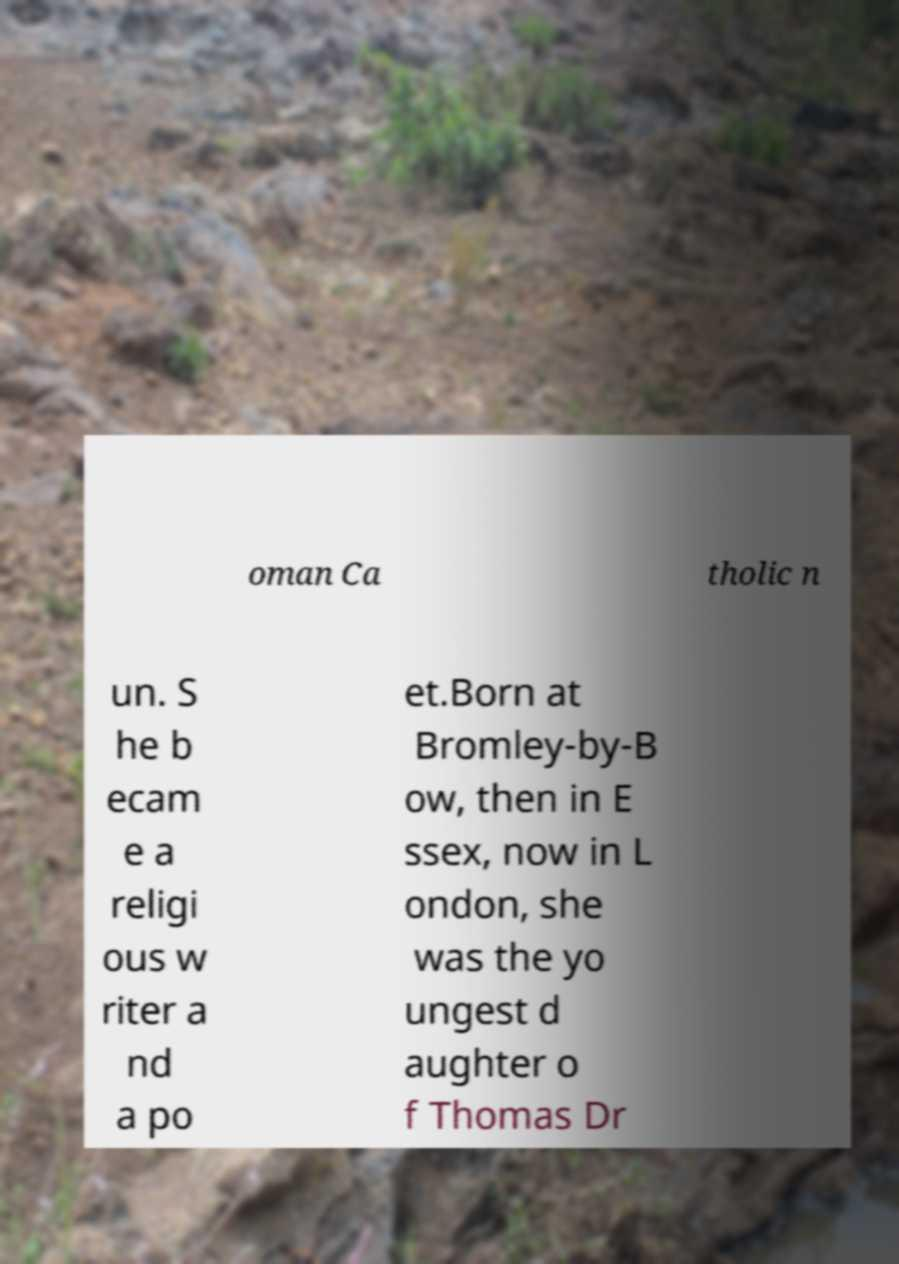For documentation purposes, I need the text within this image transcribed. Could you provide that? oman Ca tholic n un. S he b ecam e a religi ous w riter a nd a po et.Born at Bromley-by-B ow, then in E ssex, now in L ondon, she was the yo ungest d aughter o f Thomas Dr 